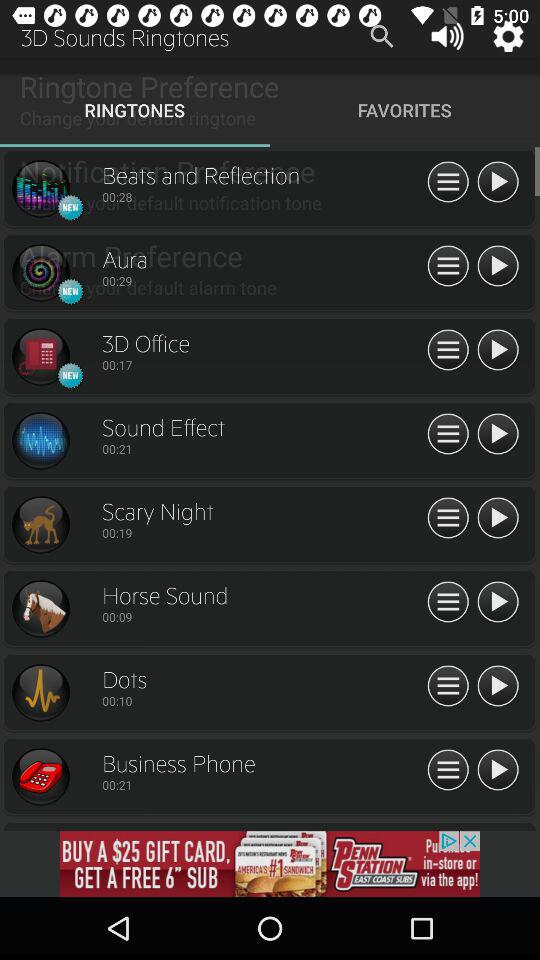What is the duration of the 3D office? The duration of the 3D office is 00:17. 